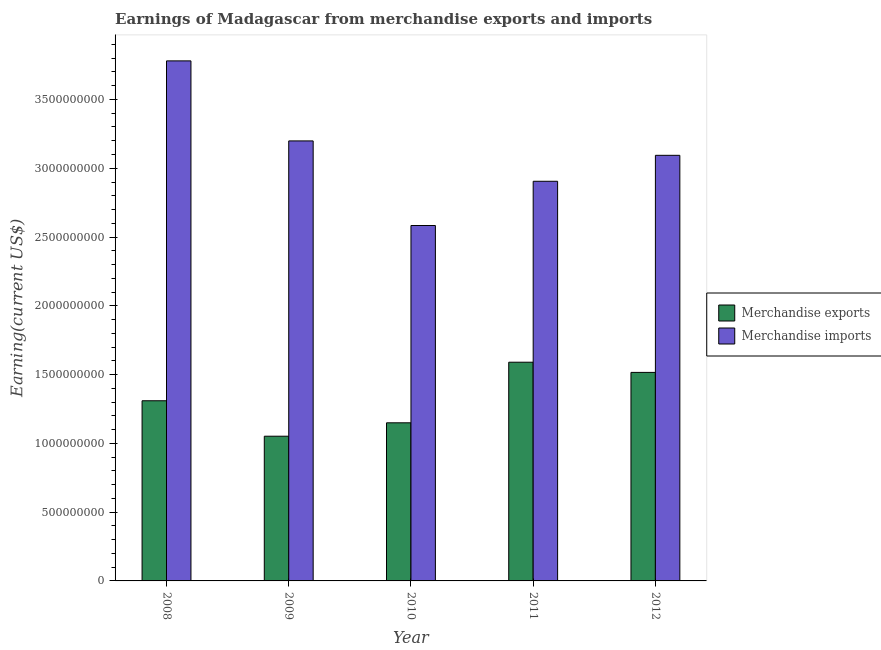How many groups of bars are there?
Ensure brevity in your answer.  5. Are the number of bars per tick equal to the number of legend labels?
Provide a succinct answer. Yes. Are the number of bars on each tick of the X-axis equal?
Your answer should be compact. Yes. How many bars are there on the 2nd tick from the left?
Ensure brevity in your answer.  2. What is the earnings from merchandise exports in 2009?
Keep it short and to the point. 1.05e+09. Across all years, what is the maximum earnings from merchandise exports?
Offer a very short reply. 1.59e+09. Across all years, what is the minimum earnings from merchandise imports?
Give a very brief answer. 2.58e+09. In which year was the earnings from merchandise exports minimum?
Offer a terse response. 2009. What is the total earnings from merchandise imports in the graph?
Offer a terse response. 1.56e+1. What is the difference between the earnings from merchandise imports in 2009 and that in 2012?
Your response must be concise. 1.05e+08. What is the difference between the earnings from merchandise imports in 2010 and the earnings from merchandise exports in 2009?
Your answer should be very brief. -6.15e+08. What is the average earnings from merchandise exports per year?
Provide a succinct answer. 1.32e+09. In the year 2012, what is the difference between the earnings from merchandise imports and earnings from merchandise exports?
Make the answer very short. 0. What is the ratio of the earnings from merchandise exports in 2010 to that in 2011?
Ensure brevity in your answer.  0.72. What is the difference between the highest and the second highest earnings from merchandise imports?
Offer a very short reply. 5.82e+08. What is the difference between the highest and the lowest earnings from merchandise imports?
Make the answer very short. 1.20e+09. In how many years, is the earnings from merchandise exports greater than the average earnings from merchandise exports taken over all years?
Keep it short and to the point. 2. What does the 1st bar from the left in 2011 represents?
Keep it short and to the point. Merchandise exports. How many years are there in the graph?
Provide a succinct answer. 5. What is the difference between two consecutive major ticks on the Y-axis?
Your answer should be compact. 5.00e+08. Does the graph contain grids?
Offer a very short reply. No. Where does the legend appear in the graph?
Provide a succinct answer. Center right. How are the legend labels stacked?
Keep it short and to the point. Vertical. What is the title of the graph?
Your answer should be very brief. Earnings of Madagascar from merchandise exports and imports. Does "Urban agglomerations" appear as one of the legend labels in the graph?
Ensure brevity in your answer.  No. What is the label or title of the Y-axis?
Give a very brief answer. Earning(current US$). What is the Earning(current US$) in Merchandise exports in 2008?
Your answer should be very brief. 1.31e+09. What is the Earning(current US$) of Merchandise imports in 2008?
Ensure brevity in your answer.  3.78e+09. What is the Earning(current US$) of Merchandise exports in 2009?
Your response must be concise. 1.05e+09. What is the Earning(current US$) in Merchandise imports in 2009?
Your answer should be compact. 3.20e+09. What is the Earning(current US$) of Merchandise exports in 2010?
Make the answer very short. 1.15e+09. What is the Earning(current US$) in Merchandise imports in 2010?
Offer a terse response. 2.58e+09. What is the Earning(current US$) of Merchandise exports in 2011?
Provide a short and direct response. 1.59e+09. What is the Earning(current US$) of Merchandise imports in 2011?
Keep it short and to the point. 2.91e+09. What is the Earning(current US$) in Merchandise exports in 2012?
Provide a succinct answer. 1.52e+09. What is the Earning(current US$) in Merchandise imports in 2012?
Provide a succinct answer. 3.09e+09. Across all years, what is the maximum Earning(current US$) in Merchandise exports?
Offer a terse response. 1.59e+09. Across all years, what is the maximum Earning(current US$) in Merchandise imports?
Ensure brevity in your answer.  3.78e+09. Across all years, what is the minimum Earning(current US$) of Merchandise exports?
Your response must be concise. 1.05e+09. Across all years, what is the minimum Earning(current US$) of Merchandise imports?
Provide a short and direct response. 2.58e+09. What is the total Earning(current US$) of Merchandise exports in the graph?
Offer a very short reply. 6.62e+09. What is the total Earning(current US$) of Merchandise imports in the graph?
Provide a succinct answer. 1.56e+1. What is the difference between the Earning(current US$) in Merchandise exports in 2008 and that in 2009?
Ensure brevity in your answer.  2.58e+08. What is the difference between the Earning(current US$) in Merchandise imports in 2008 and that in 2009?
Offer a terse response. 5.82e+08. What is the difference between the Earning(current US$) in Merchandise exports in 2008 and that in 2010?
Ensure brevity in your answer.  1.60e+08. What is the difference between the Earning(current US$) of Merchandise imports in 2008 and that in 2010?
Keep it short and to the point. 1.20e+09. What is the difference between the Earning(current US$) of Merchandise exports in 2008 and that in 2011?
Provide a short and direct response. -2.80e+08. What is the difference between the Earning(current US$) of Merchandise imports in 2008 and that in 2011?
Make the answer very short. 8.75e+08. What is the difference between the Earning(current US$) in Merchandise exports in 2008 and that in 2012?
Give a very brief answer. -2.06e+08. What is the difference between the Earning(current US$) of Merchandise imports in 2008 and that in 2012?
Your answer should be very brief. 6.87e+08. What is the difference between the Earning(current US$) of Merchandise exports in 2009 and that in 2010?
Offer a terse response. -9.75e+07. What is the difference between the Earning(current US$) in Merchandise imports in 2009 and that in 2010?
Offer a very short reply. 6.15e+08. What is the difference between the Earning(current US$) of Merchandise exports in 2009 and that in 2011?
Provide a short and direct response. -5.38e+08. What is the difference between the Earning(current US$) of Merchandise imports in 2009 and that in 2011?
Your answer should be compact. 2.93e+08. What is the difference between the Earning(current US$) in Merchandise exports in 2009 and that in 2012?
Provide a short and direct response. -4.64e+08. What is the difference between the Earning(current US$) in Merchandise imports in 2009 and that in 2012?
Make the answer very short. 1.05e+08. What is the difference between the Earning(current US$) in Merchandise exports in 2010 and that in 2011?
Your answer should be very brief. -4.41e+08. What is the difference between the Earning(current US$) in Merchandise imports in 2010 and that in 2011?
Make the answer very short. -3.22e+08. What is the difference between the Earning(current US$) of Merchandise exports in 2010 and that in 2012?
Offer a very short reply. -3.66e+08. What is the difference between the Earning(current US$) of Merchandise imports in 2010 and that in 2012?
Your response must be concise. -5.10e+08. What is the difference between the Earning(current US$) of Merchandise exports in 2011 and that in 2012?
Provide a short and direct response. 7.41e+07. What is the difference between the Earning(current US$) in Merchandise imports in 2011 and that in 2012?
Provide a succinct answer. -1.89e+08. What is the difference between the Earning(current US$) of Merchandise exports in 2008 and the Earning(current US$) of Merchandise imports in 2009?
Make the answer very short. -1.89e+09. What is the difference between the Earning(current US$) of Merchandise exports in 2008 and the Earning(current US$) of Merchandise imports in 2010?
Keep it short and to the point. -1.27e+09. What is the difference between the Earning(current US$) of Merchandise exports in 2008 and the Earning(current US$) of Merchandise imports in 2011?
Provide a short and direct response. -1.60e+09. What is the difference between the Earning(current US$) in Merchandise exports in 2008 and the Earning(current US$) in Merchandise imports in 2012?
Keep it short and to the point. -1.78e+09. What is the difference between the Earning(current US$) in Merchandise exports in 2009 and the Earning(current US$) in Merchandise imports in 2010?
Offer a terse response. -1.53e+09. What is the difference between the Earning(current US$) of Merchandise exports in 2009 and the Earning(current US$) of Merchandise imports in 2011?
Make the answer very short. -1.85e+09. What is the difference between the Earning(current US$) of Merchandise exports in 2009 and the Earning(current US$) of Merchandise imports in 2012?
Your answer should be very brief. -2.04e+09. What is the difference between the Earning(current US$) of Merchandise exports in 2010 and the Earning(current US$) of Merchandise imports in 2011?
Your answer should be very brief. -1.76e+09. What is the difference between the Earning(current US$) of Merchandise exports in 2010 and the Earning(current US$) of Merchandise imports in 2012?
Your response must be concise. -1.94e+09. What is the difference between the Earning(current US$) of Merchandise exports in 2011 and the Earning(current US$) of Merchandise imports in 2012?
Your answer should be very brief. -1.50e+09. What is the average Earning(current US$) in Merchandise exports per year?
Give a very brief answer. 1.32e+09. What is the average Earning(current US$) in Merchandise imports per year?
Your answer should be very brief. 3.11e+09. In the year 2008, what is the difference between the Earning(current US$) of Merchandise exports and Earning(current US$) of Merchandise imports?
Ensure brevity in your answer.  -2.47e+09. In the year 2009, what is the difference between the Earning(current US$) in Merchandise exports and Earning(current US$) in Merchandise imports?
Offer a terse response. -2.15e+09. In the year 2010, what is the difference between the Earning(current US$) of Merchandise exports and Earning(current US$) of Merchandise imports?
Provide a succinct answer. -1.43e+09. In the year 2011, what is the difference between the Earning(current US$) in Merchandise exports and Earning(current US$) in Merchandise imports?
Ensure brevity in your answer.  -1.32e+09. In the year 2012, what is the difference between the Earning(current US$) in Merchandise exports and Earning(current US$) in Merchandise imports?
Give a very brief answer. -1.58e+09. What is the ratio of the Earning(current US$) in Merchandise exports in 2008 to that in 2009?
Provide a succinct answer. 1.25. What is the ratio of the Earning(current US$) of Merchandise imports in 2008 to that in 2009?
Make the answer very short. 1.18. What is the ratio of the Earning(current US$) in Merchandise exports in 2008 to that in 2010?
Your response must be concise. 1.14. What is the ratio of the Earning(current US$) in Merchandise imports in 2008 to that in 2010?
Your response must be concise. 1.46. What is the ratio of the Earning(current US$) of Merchandise exports in 2008 to that in 2011?
Ensure brevity in your answer.  0.82. What is the ratio of the Earning(current US$) in Merchandise imports in 2008 to that in 2011?
Give a very brief answer. 1.3. What is the ratio of the Earning(current US$) in Merchandise exports in 2008 to that in 2012?
Make the answer very short. 0.86. What is the ratio of the Earning(current US$) in Merchandise imports in 2008 to that in 2012?
Offer a terse response. 1.22. What is the ratio of the Earning(current US$) of Merchandise exports in 2009 to that in 2010?
Provide a succinct answer. 0.92. What is the ratio of the Earning(current US$) in Merchandise imports in 2009 to that in 2010?
Offer a very short reply. 1.24. What is the ratio of the Earning(current US$) of Merchandise exports in 2009 to that in 2011?
Provide a succinct answer. 0.66. What is the ratio of the Earning(current US$) of Merchandise imports in 2009 to that in 2011?
Provide a succinct answer. 1.1. What is the ratio of the Earning(current US$) in Merchandise exports in 2009 to that in 2012?
Your answer should be compact. 0.69. What is the ratio of the Earning(current US$) of Merchandise imports in 2009 to that in 2012?
Make the answer very short. 1.03. What is the ratio of the Earning(current US$) of Merchandise exports in 2010 to that in 2011?
Keep it short and to the point. 0.72. What is the ratio of the Earning(current US$) of Merchandise imports in 2010 to that in 2011?
Your answer should be very brief. 0.89. What is the ratio of the Earning(current US$) in Merchandise exports in 2010 to that in 2012?
Make the answer very short. 0.76. What is the ratio of the Earning(current US$) in Merchandise imports in 2010 to that in 2012?
Provide a short and direct response. 0.84. What is the ratio of the Earning(current US$) in Merchandise exports in 2011 to that in 2012?
Offer a terse response. 1.05. What is the ratio of the Earning(current US$) in Merchandise imports in 2011 to that in 2012?
Provide a short and direct response. 0.94. What is the difference between the highest and the second highest Earning(current US$) in Merchandise exports?
Ensure brevity in your answer.  7.41e+07. What is the difference between the highest and the second highest Earning(current US$) of Merchandise imports?
Your answer should be very brief. 5.82e+08. What is the difference between the highest and the lowest Earning(current US$) in Merchandise exports?
Keep it short and to the point. 5.38e+08. What is the difference between the highest and the lowest Earning(current US$) in Merchandise imports?
Your answer should be compact. 1.20e+09. 